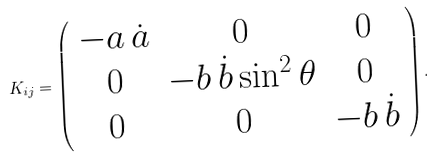<formula> <loc_0><loc_0><loc_500><loc_500>K _ { i j } = \left ( \begin{array} { c c c } - a \, \dot { a } & 0 & 0 \\ 0 & - b \, \dot { b } \sin ^ { 2 } \theta & 0 \\ 0 & 0 & - b \, \dot { b } \end{array} \right ) .</formula> 